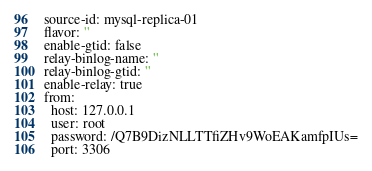<code> <loc_0><loc_0><loc_500><loc_500><_YAML_>source-id: mysql-replica-01
flavor: ''
enable-gtid: false
relay-binlog-name: ''
relay-binlog-gtid: ''
enable-relay: true
from:
  host: 127.0.0.1
  user: root
  password: /Q7B9DizNLLTTfiZHv9WoEAKamfpIUs=
  port: 3306
</code> 